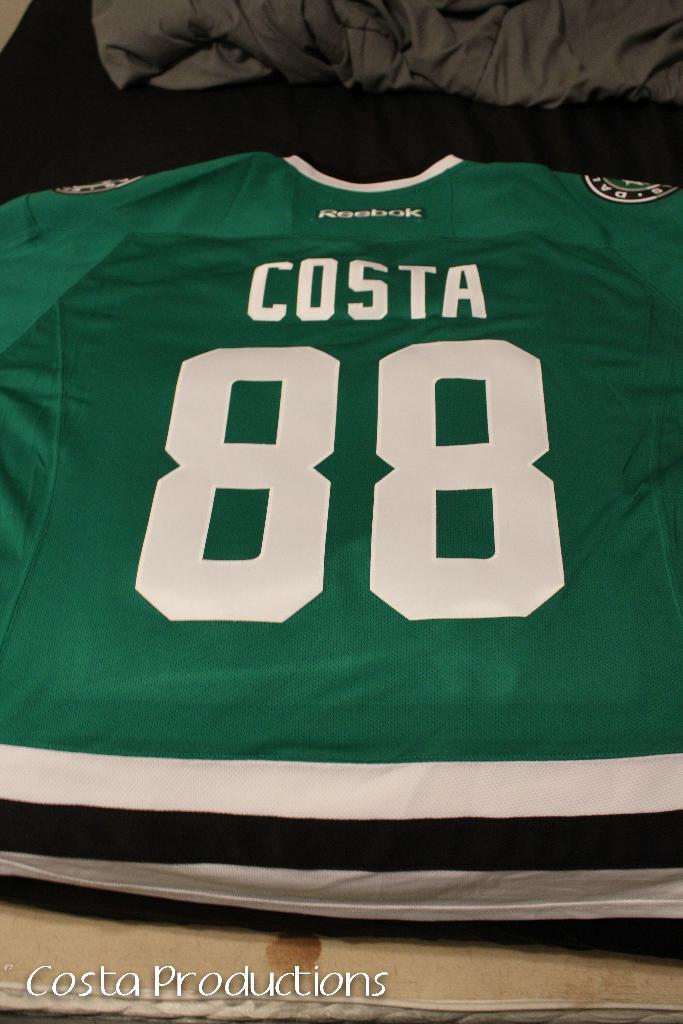Is that a costa jersey?
Ensure brevity in your answer.  Yes. What number is on this jersey?
Provide a short and direct response. 88. 